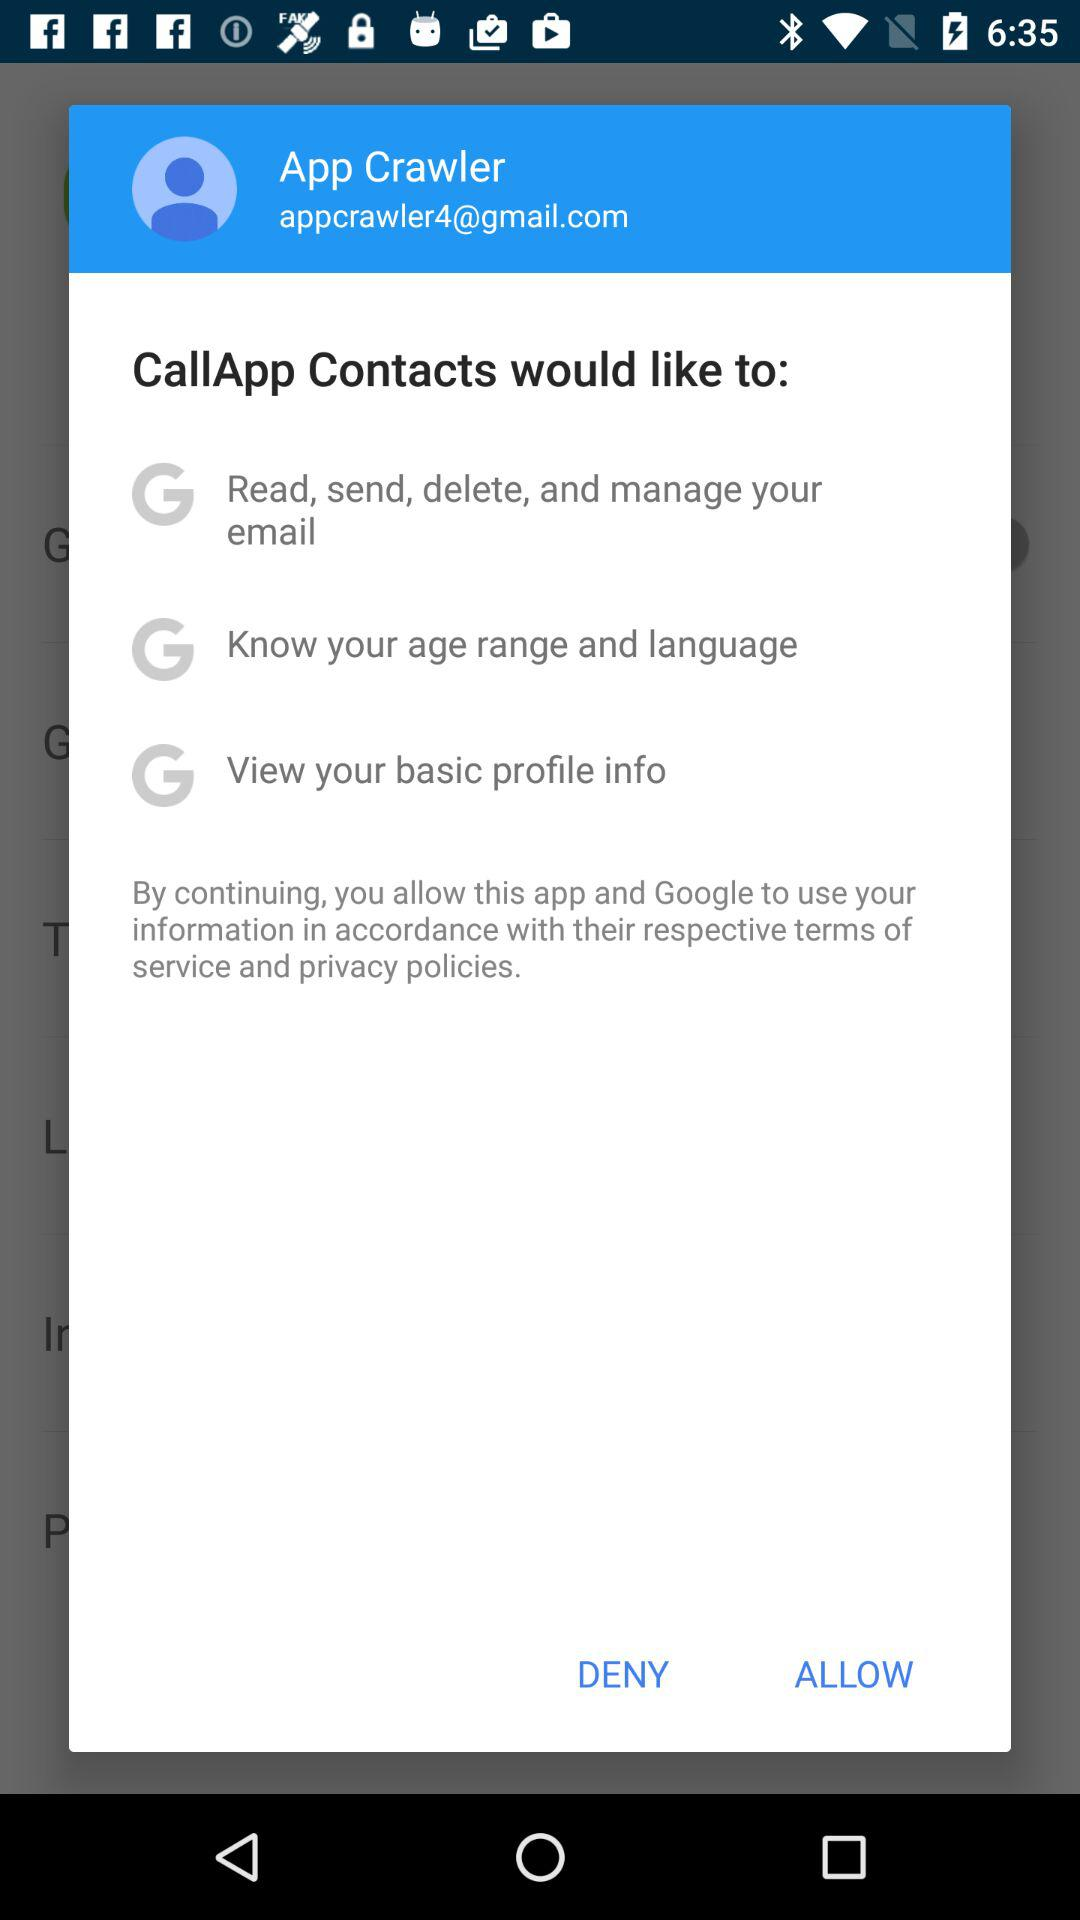How many permissions does the app want to access in total?
Answer the question using a single word or phrase. 3 